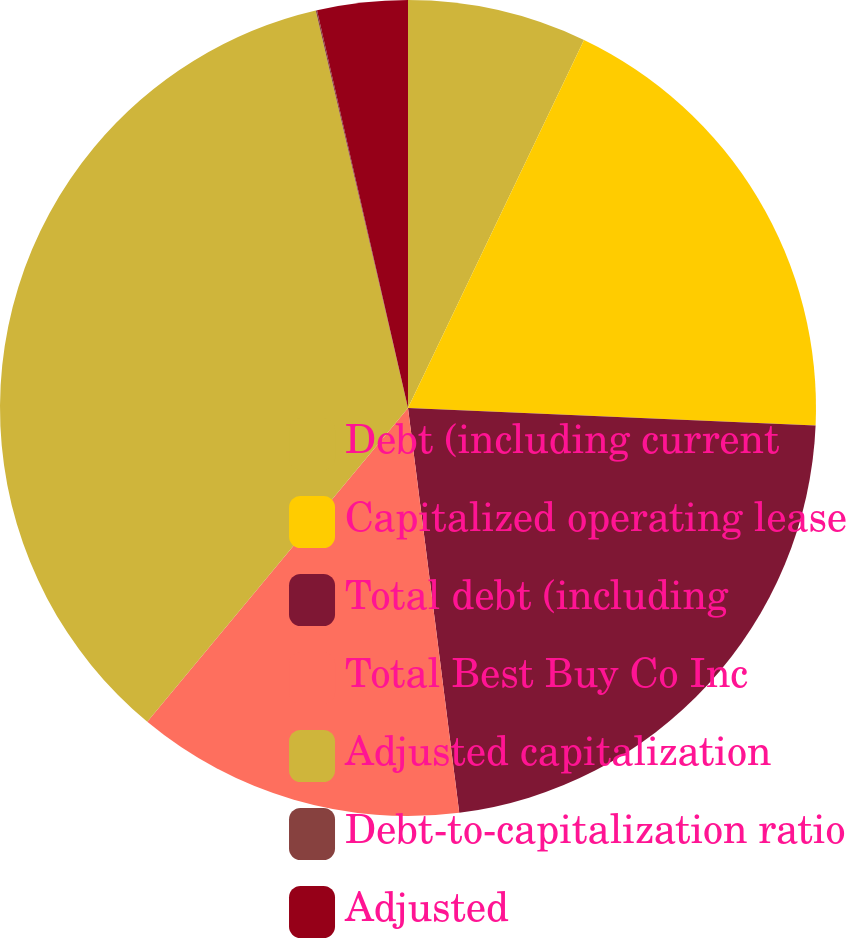Convert chart to OTSL. <chart><loc_0><loc_0><loc_500><loc_500><pie_chart><fcel>Debt (including current<fcel>Capitalized operating lease<fcel>Total debt (including<fcel>Total Best Buy Co Inc<fcel>Adjusted capitalization<fcel>Debt-to-capitalization ratio<fcel>Adjusted<nl><fcel>7.1%<fcel>18.59%<fcel>22.31%<fcel>13.04%<fcel>35.34%<fcel>0.05%<fcel>3.58%<nl></chart> 